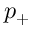<formula> <loc_0><loc_0><loc_500><loc_500>p _ { + }</formula> 